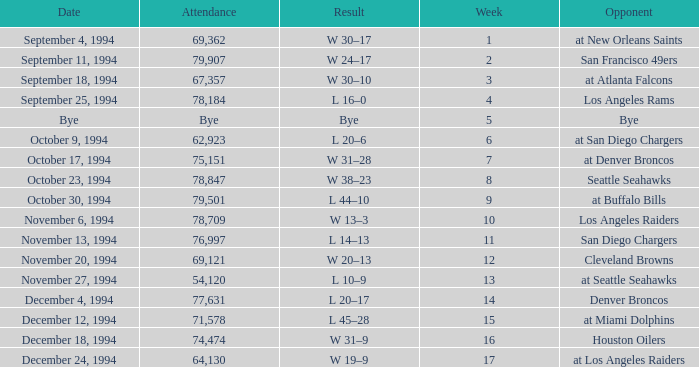What was the score of the Chiefs pre-Week 16 game that 69,362 people attended? W 30–17. 